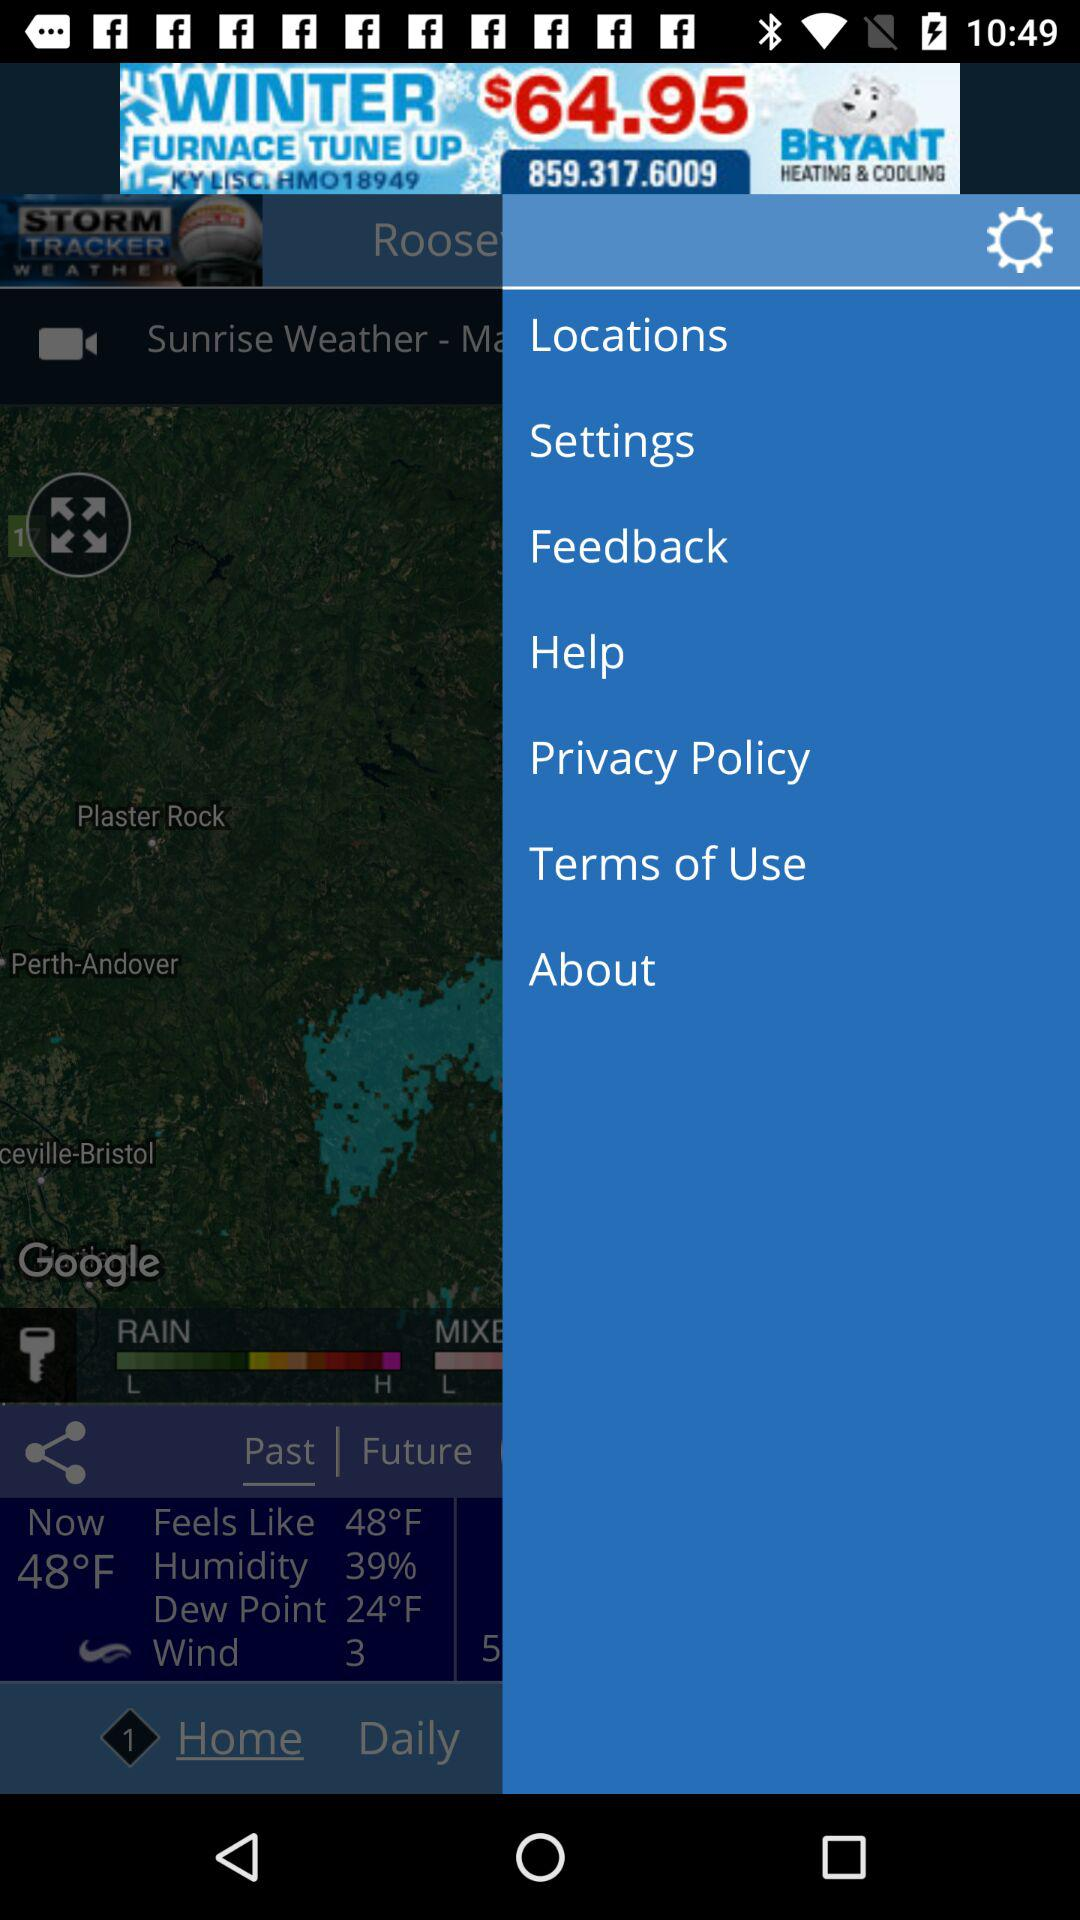How many degrees Fahrenheit is the difference between the current temperature and the dew point? 24 